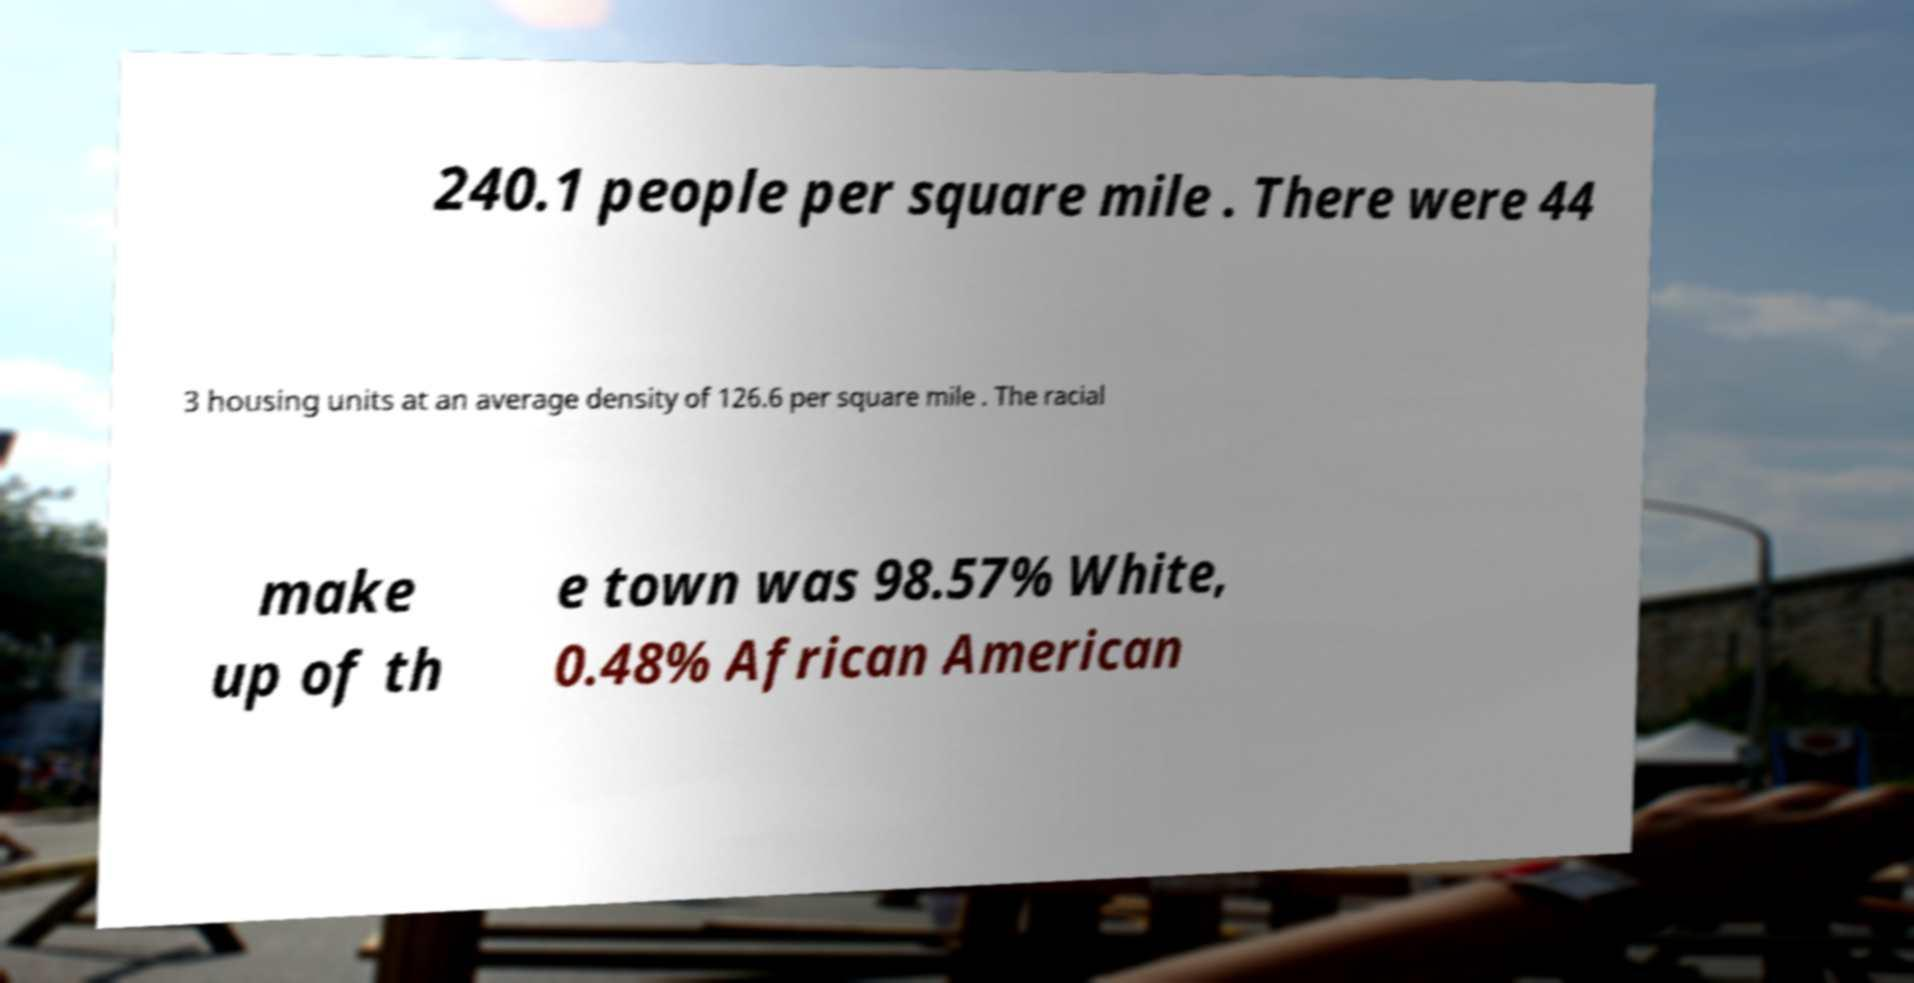Could you extract and type out the text from this image? 240.1 people per square mile . There were 44 3 housing units at an average density of 126.6 per square mile . The racial make up of th e town was 98.57% White, 0.48% African American 